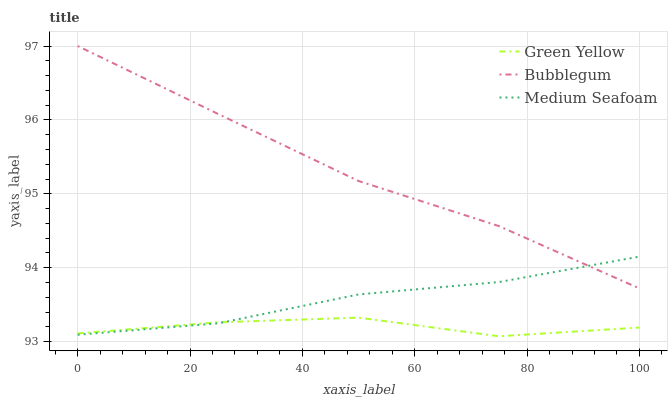Does Green Yellow have the minimum area under the curve?
Answer yes or no. Yes. Does Bubblegum have the maximum area under the curve?
Answer yes or no. Yes. Does Medium Seafoam have the minimum area under the curve?
Answer yes or no. No. Does Medium Seafoam have the maximum area under the curve?
Answer yes or no. No. Is Bubblegum the smoothest?
Answer yes or no. Yes. Is Green Yellow the roughest?
Answer yes or no. Yes. Is Medium Seafoam the smoothest?
Answer yes or no. No. Is Medium Seafoam the roughest?
Answer yes or no. No. Does Green Yellow have the lowest value?
Answer yes or no. Yes. Does Medium Seafoam have the lowest value?
Answer yes or no. No. Does Bubblegum have the highest value?
Answer yes or no. Yes. Does Medium Seafoam have the highest value?
Answer yes or no. No. Is Green Yellow less than Bubblegum?
Answer yes or no. Yes. Is Bubblegum greater than Green Yellow?
Answer yes or no. Yes. Does Bubblegum intersect Medium Seafoam?
Answer yes or no. Yes. Is Bubblegum less than Medium Seafoam?
Answer yes or no. No. Is Bubblegum greater than Medium Seafoam?
Answer yes or no. No. Does Green Yellow intersect Bubblegum?
Answer yes or no. No. 